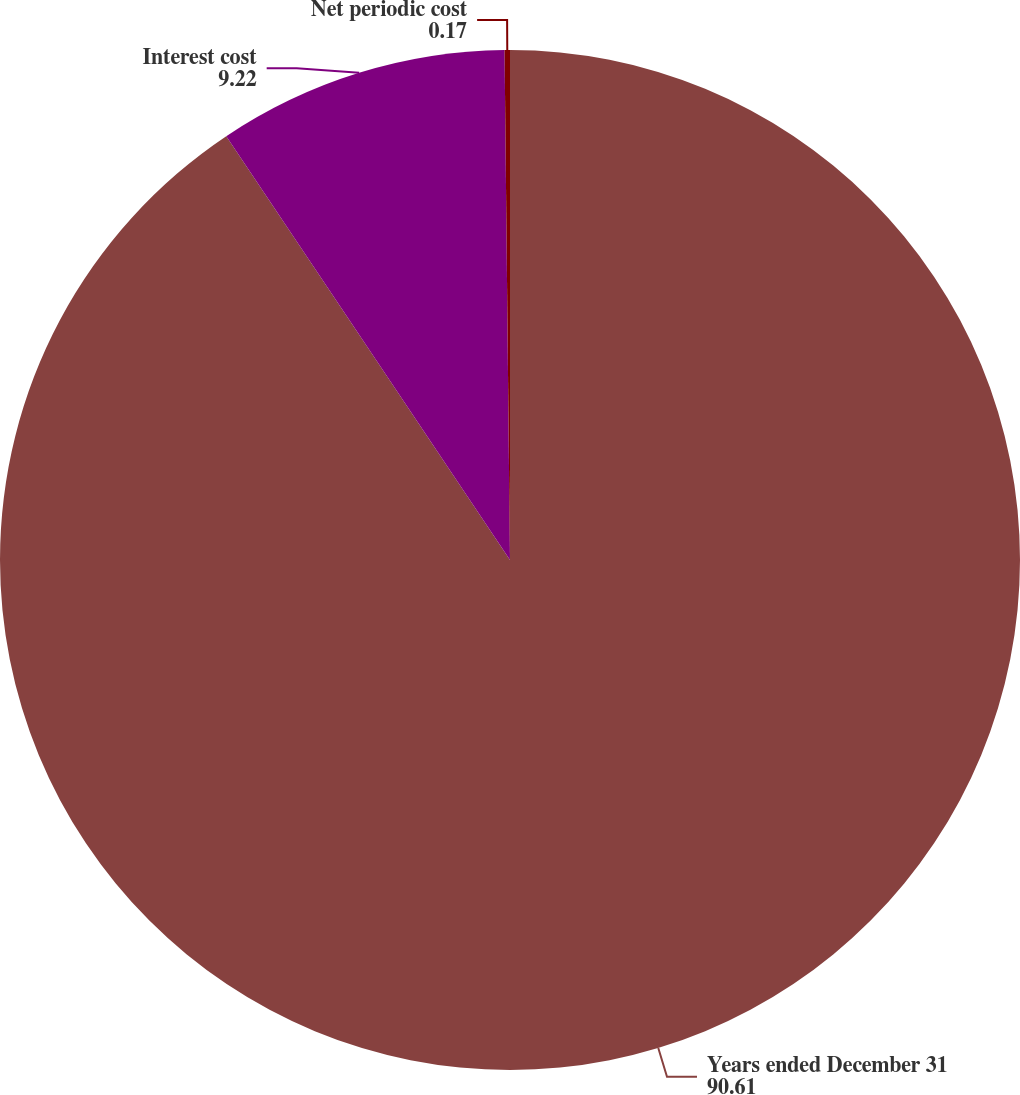Convert chart. <chart><loc_0><loc_0><loc_500><loc_500><pie_chart><fcel>Years ended December 31<fcel>Interest cost<fcel>Net periodic cost<nl><fcel>90.61%<fcel>9.22%<fcel>0.17%<nl></chart> 